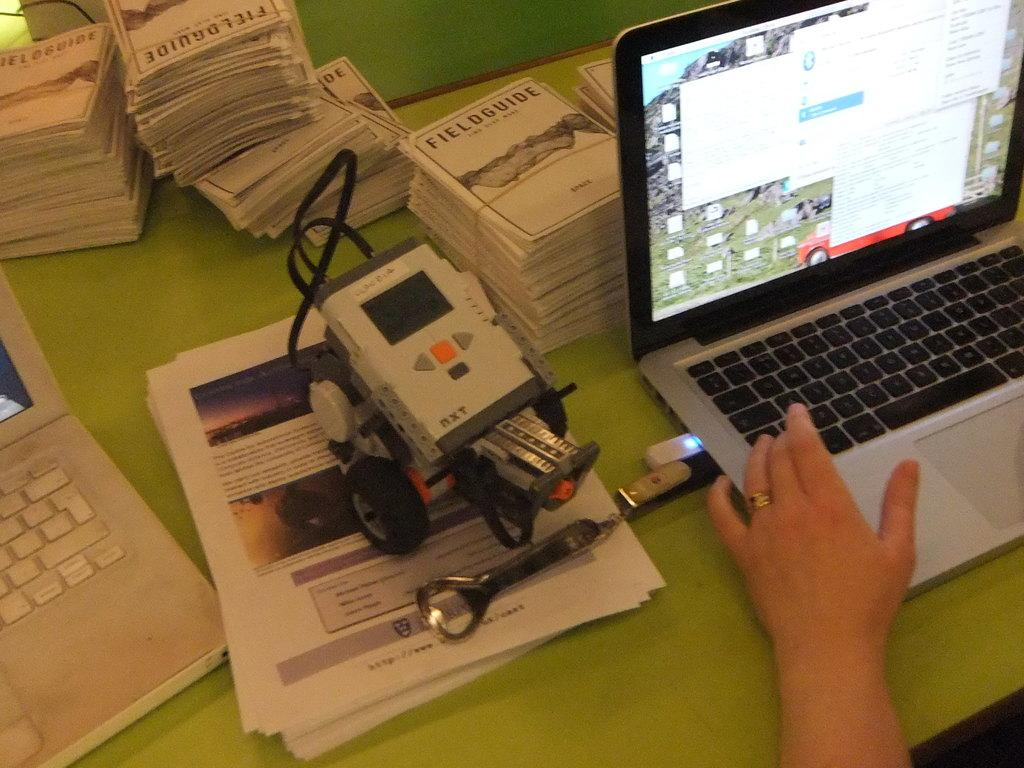<image>
Describe the image concisely. someone using laptop and next to it is gadget on stack of papers and behind them is bundles of fieldguides 